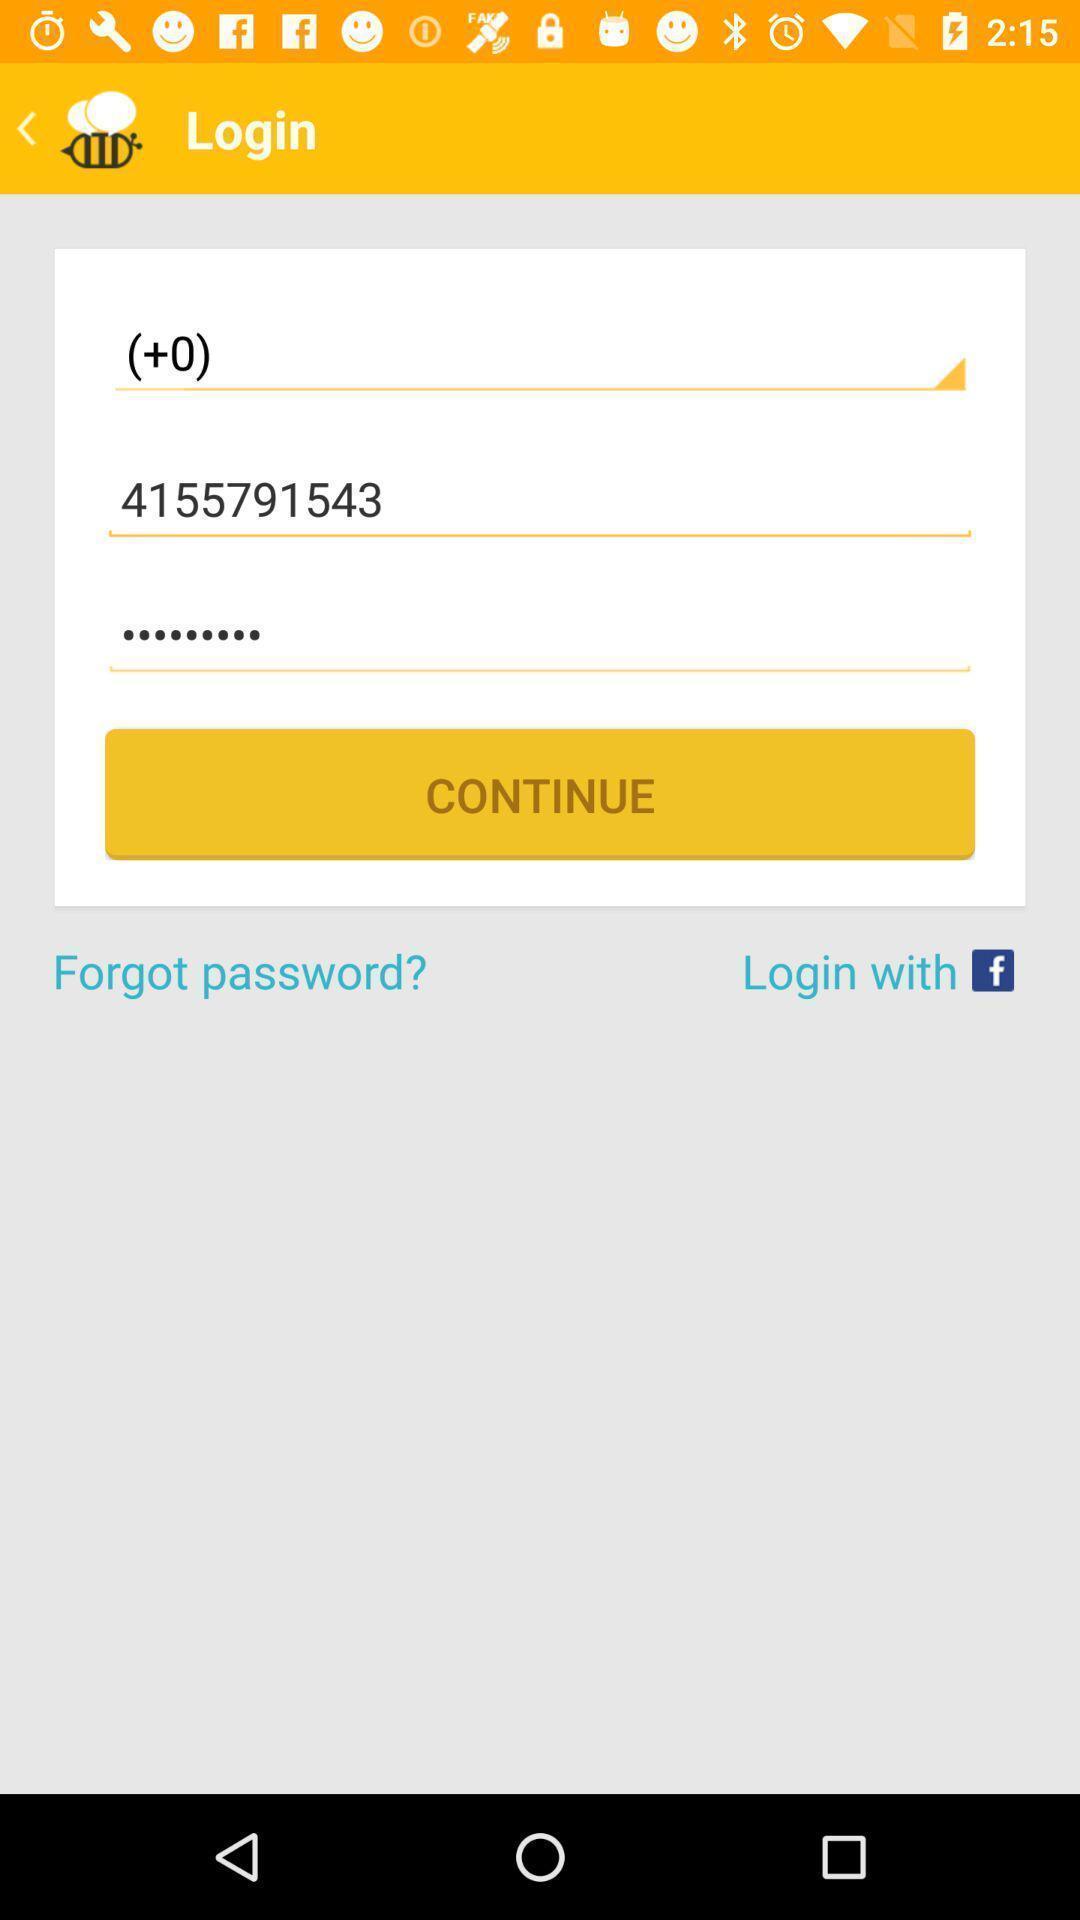Describe the content in this image. Page showing log in credentials. 